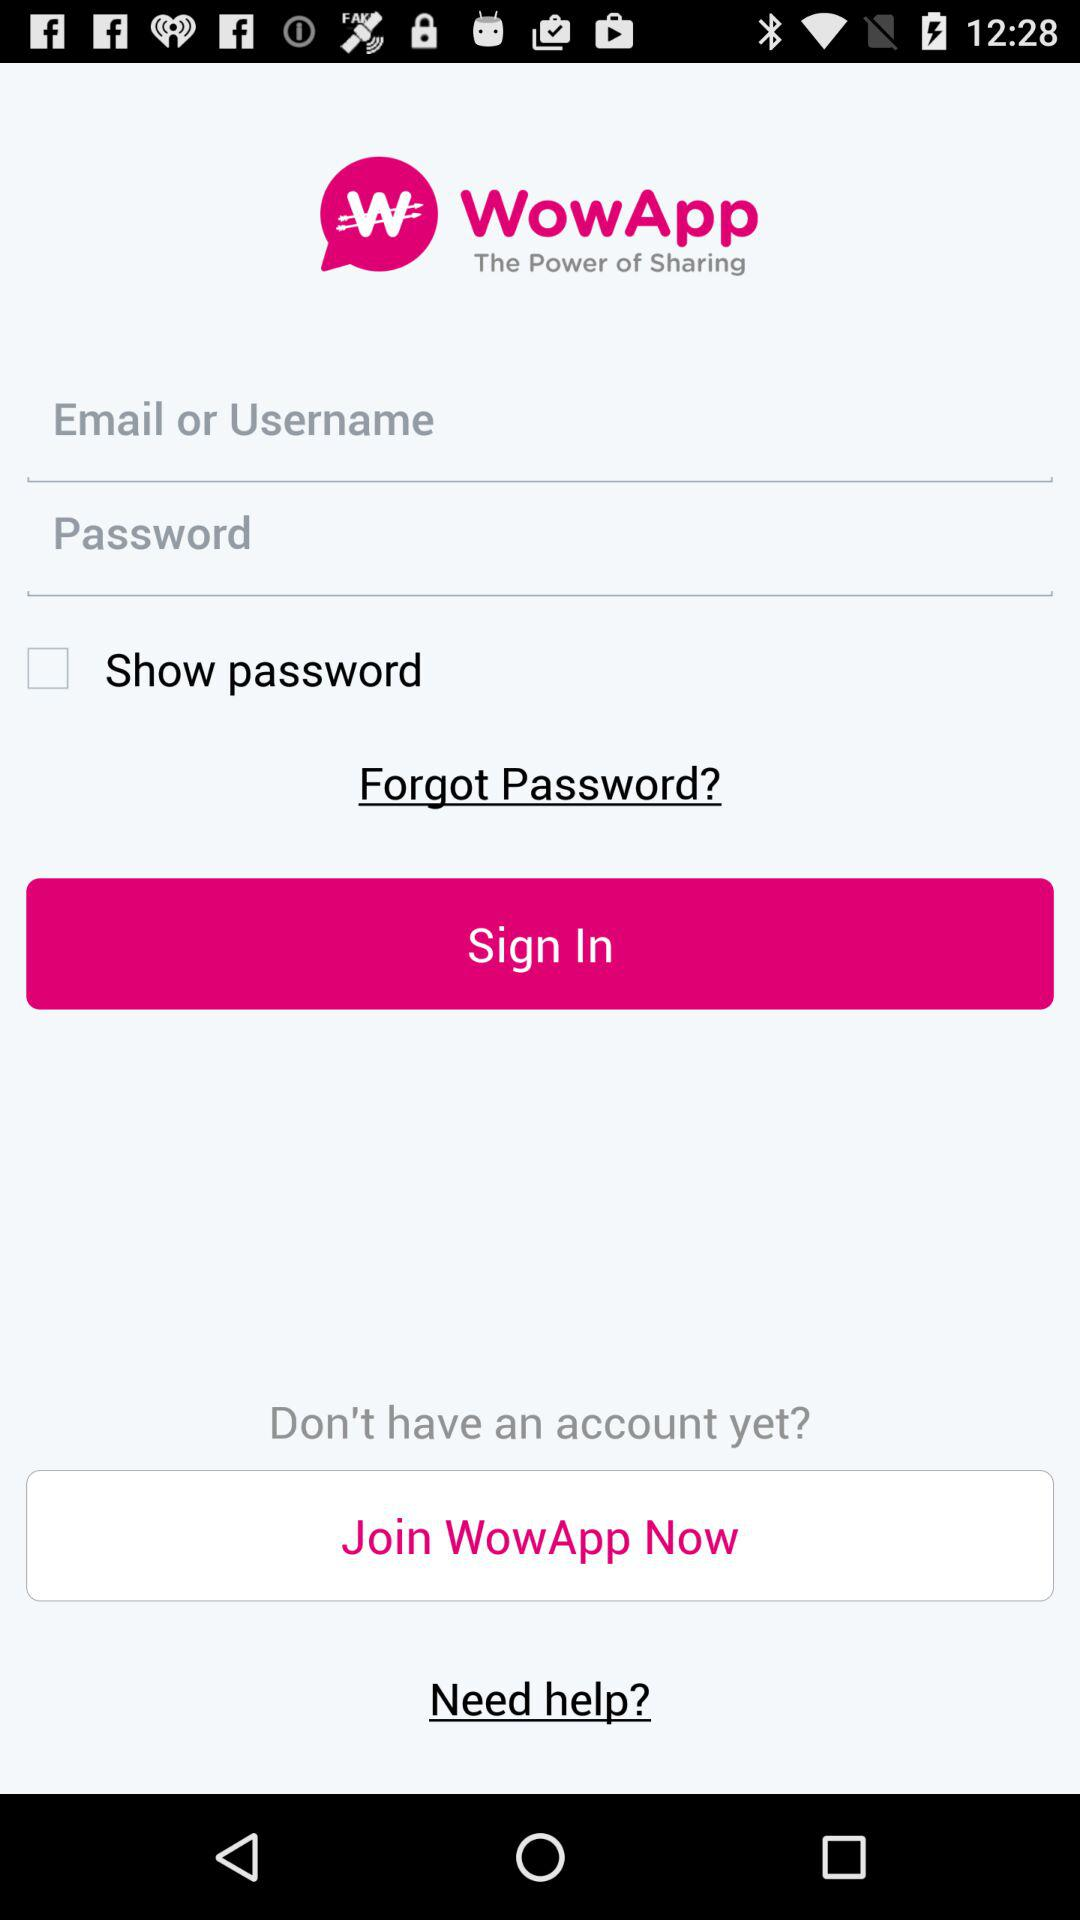What is the application name? The application name is "WowApp". 